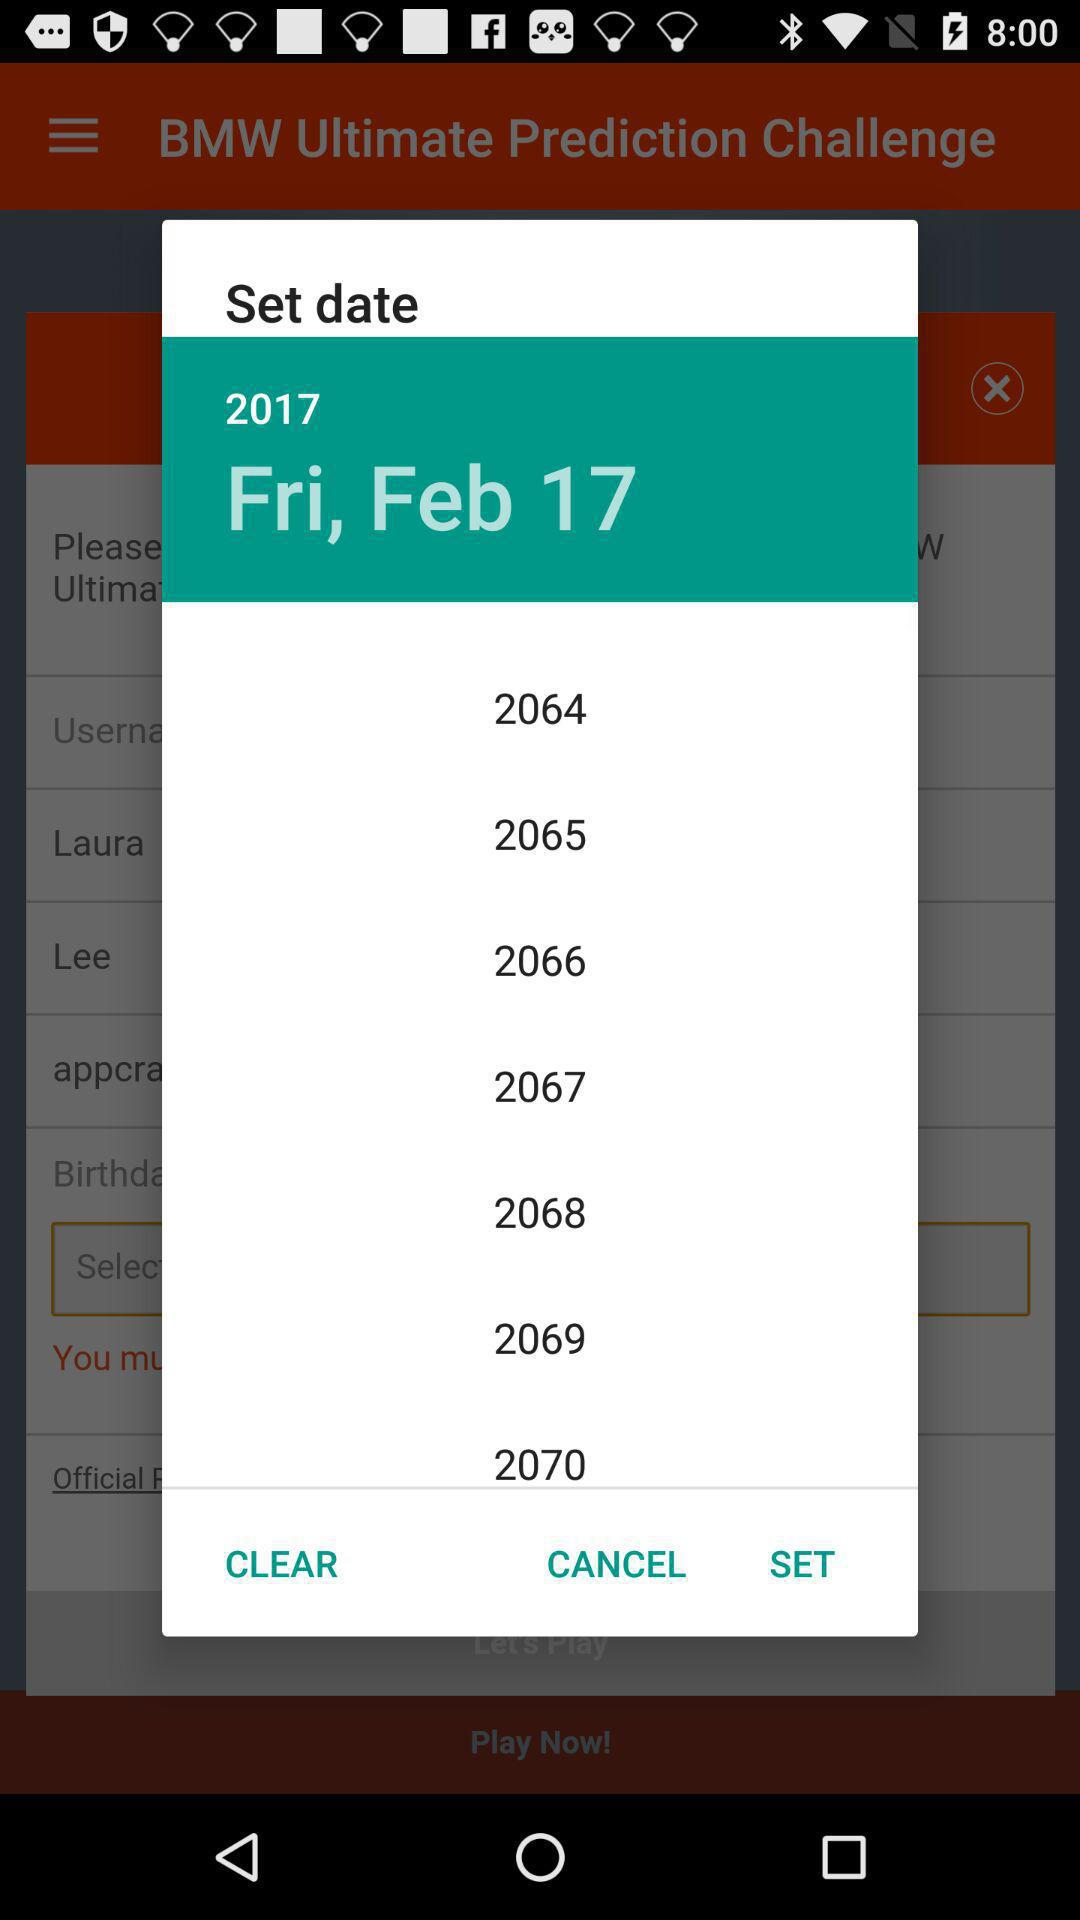What is the selected date? The selected date is Friday, February 17, 2017. 